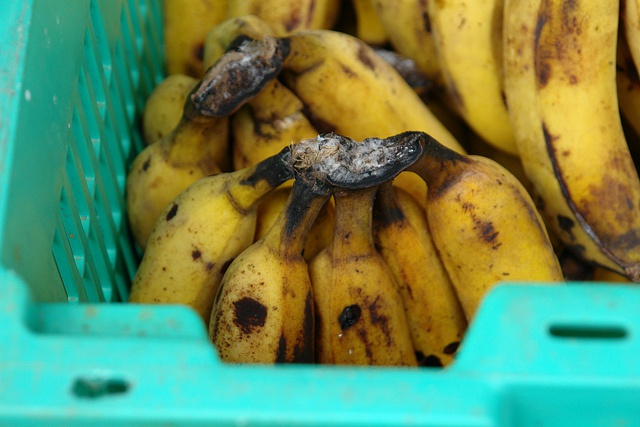Describe the objects in this image and their specific colors. I can see banana in turquoise, olive, and black tones, banana in turquoise, olive, black, and maroon tones, banana in turquoise, olive, orange, tan, and gold tones, banana in turquoise, olive, and gold tones, and banana in turquoise and olive tones in this image. 